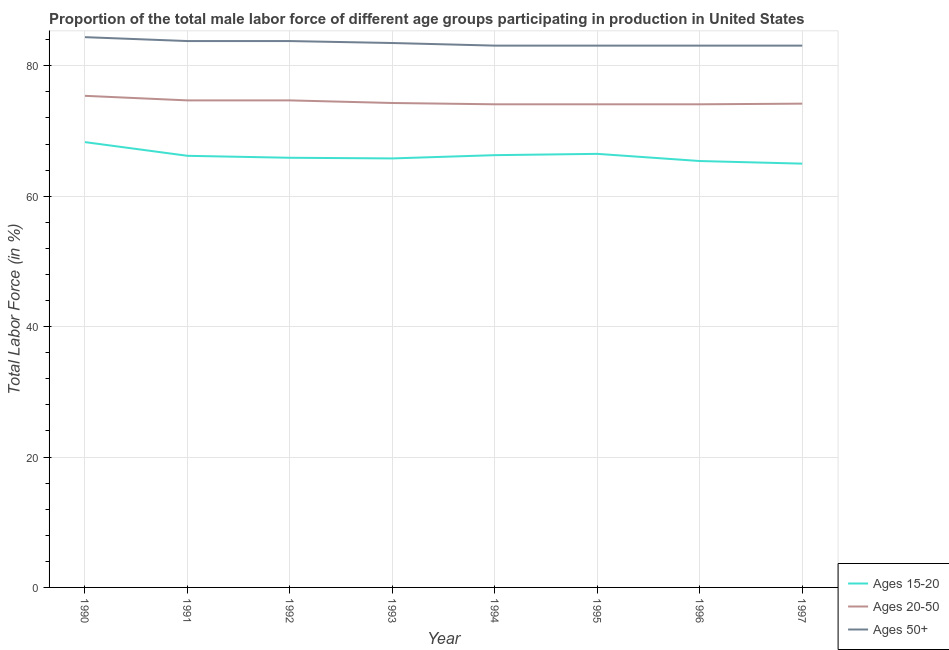How many different coloured lines are there?
Give a very brief answer. 3. What is the percentage of male labor force within the age group 20-50 in 1996?
Ensure brevity in your answer.  74.1. Across all years, what is the maximum percentage of male labor force within the age group 20-50?
Your answer should be very brief. 75.4. Across all years, what is the minimum percentage of male labor force within the age group 15-20?
Your answer should be compact. 65. What is the total percentage of male labor force above age 50 in the graph?
Make the answer very short. 667.9. What is the difference between the percentage of male labor force above age 50 in 1992 and that in 1997?
Your response must be concise. 0.7. What is the difference between the percentage of male labor force within the age group 20-50 in 1994 and the percentage of male labor force within the age group 15-20 in 1993?
Provide a succinct answer. 8.3. What is the average percentage of male labor force within the age group 15-20 per year?
Your answer should be very brief. 66.18. In the year 1997, what is the difference between the percentage of male labor force above age 50 and percentage of male labor force within the age group 15-20?
Offer a very short reply. 18.1. In how many years, is the percentage of male labor force above age 50 greater than 64 %?
Offer a very short reply. 8. What is the ratio of the percentage of male labor force within the age group 20-50 in 1992 to that in 1994?
Give a very brief answer. 1.01. Is the percentage of male labor force within the age group 15-20 in 1990 less than that in 1995?
Offer a terse response. No. Is the difference between the percentage of male labor force within the age group 15-20 in 1993 and 1994 greater than the difference between the percentage of male labor force within the age group 20-50 in 1993 and 1994?
Give a very brief answer. No. What is the difference between the highest and the second highest percentage of male labor force above age 50?
Offer a very short reply. 0.6. What is the difference between the highest and the lowest percentage of male labor force within the age group 20-50?
Provide a succinct answer. 1.3. Does the percentage of male labor force within the age group 15-20 monotonically increase over the years?
Offer a very short reply. No. Is the percentage of male labor force within the age group 15-20 strictly greater than the percentage of male labor force above age 50 over the years?
Your response must be concise. No. How many lines are there?
Make the answer very short. 3. How many years are there in the graph?
Provide a succinct answer. 8. Does the graph contain any zero values?
Provide a succinct answer. No. Does the graph contain grids?
Your response must be concise. Yes. What is the title of the graph?
Make the answer very short. Proportion of the total male labor force of different age groups participating in production in United States. What is the label or title of the X-axis?
Provide a succinct answer. Year. What is the Total Labor Force (in %) of Ages 15-20 in 1990?
Make the answer very short. 68.3. What is the Total Labor Force (in %) of Ages 20-50 in 1990?
Your response must be concise. 75.4. What is the Total Labor Force (in %) of Ages 50+ in 1990?
Provide a short and direct response. 84.4. What is the Total Labor Force (in %) in Ages 15-20 in 1991?
Offer a very short reply. 66.2. What is the Total Labor Force (in %) of Ages 20-50 in 1991?
Give a very brief answer. 74.7. What is the Total Labor Force (in %) in Ages 50+ in 1991?
Make the answer very short. 83.8. What is the Total Labor Force (in %) in Ages 15-20 in 1992?
Keep it short and to the point. 65.9. What is the Total Labor Force (in %) of Ages 20-50 in 1992?
Ensure brevity in your answer.  74.7. What is the Total Labor Force (in %) of Ages 50+ in 1992?
Offer a terse response. 83.8. What is the Total Labor Force (in %) of Ages 15-20 in 1993?
Offer a very short reply. 65.8. What is the Total Labor Force (in %) of Ages 20-50 in 1993?
Your response must be concise. 74.3. What is the Total Labor Force (in %) in Ages 50+ in 1993?
Offer a terse response. 83.5. What is the Total Labor Force (in %) of Ages 15-20 in 1994?
Your response must be concise. 66.3. What is the Total Labor Force (in %) of Ages 20-50 in 1994?
Provide a short and direct response. 74.1. What is the Total Labor Force (in %) in Ages 50+ in 1994?
Keep it short and to the point. 83.1. What is the Total Labor Force (in %) of Ages 15-20 in 1995?
Make the answer very short. 66.5. What is the Total Labor Force (in %) of Ages 20-50 in 1995?
Make the answer very short. 74.1. What is the Total Labor Force (in %) of Ages 50+ in 1995?
Offer a terse response. 83.1. What is the Total Labor Force (in %) of Ages 15-20 in 1996?
Give a very brief answer. 65.4. What is the Total Labor Force (in %) of Ages 20-50 in 1996?
Provide a short and direct response. 74.1. What is the Total Labor Force (in %) of Ages 50+ in 1996?
Give a very brief answer. 83.1. What is the Total Labor Force (in %) of Ages 20-50 in 1997?
Provide a succinct answer. 74.2. What is the Total Labor Force (in %) in Ages 50+ in 1997?
Offer a terse response. 83.1. Across all years, what is the maximum Total Labor Force (in %) in Ages 15-20?
Make the answer very short. 68.3. Across all years, what is the maximum Total Labor Force (in %) of Ages 20-50?
Offer a terse response. 75.4. Across all years, what is the maximum Total Labor Force (in %) of Ages 50+?
Your answer should be very brief. 84.4. Across all years, what is the minimum Total Labor Force (in %) of Ages 15-20?
Provide a succinct answer. 65. Across all years, what is the minimum Total Labor Force (in %) of Ages 20-50?
Keep it short and to the point. 74.1. Across all years, what is the minimum Total Labor Force (in %) in Ages 50+?
Make the answer very short. 83.1. What is the total Total Labor Force (in %) of Ages 15-20 in the graph?
Your answer should be compact. 529.4. What is the total Total Labor Force (in %) of Ages 20-50 in the graph?
Your answer should be very brief. 595.6. What is the total Total Labor Force (in %) of Ages 50+ in the graph?
Give a very brief answer. 667.9. What is the difference between the Total Labor Force (in %) in Ages 15-20 in 1990 and that in 1991?
Offer a very short reply. 2.1. What is the difference between the Total Labor Force (in %) of Ages 20-50 in 1990 and that in 1992?
Make the answer very short. 0.7. What is the difference between the Total Labor Force (in %) of Ages 50+ in 1990 and that in 1992?
Your response must be concise. 0.6. What is the difference between the Total Labor Force (in %) of Ages 20-50 in 1990 and that in 1993?
Give a very brief answer. 1.1. What is the difference between the Total Labor Force (in %) of Ages 50+ in 1990 and that in 1993?
Offer a very short reply. 0.9. What is the difference between the Total Labor Force (in %) in Ages 15-20 in 1990 and that in 1994?
Provide a succinct answer. 2. What is the difference between the Total Labor Force (in %) of Ages 50+ in 1990 and that in 1994?
Provide a succinct answer. 1.3. What is the difference between the Total Labor Force (in %) of Ages 15-20 in 1990 and that in 1995?
Provide a short and direct response. 1.8. What is the difference between the Total Labor Force (in %) of Ages 20-50 in 1990 and that in 1995?
Your answer should be very brief. 1.3. What is the difference between the Total Labor Force (in %) in Ages 50+ in 1990 and that in 1995?
Make the answer very short. 1.3. What is the difference between the Total Labor Force (in %) of Ages 20-50 in 1990 and that in 1996?
Offer a very short reply. 1.3. What is the difference between the Total Labor Force (in %) in Ages 50+ in 1990 and that in 1996?
Keep it short and to the point. 1.3. What is the difference between the Total Labor Force (in %) in Ages 15-20 in 1990 and that in 1997?
Offer a very short reply. 3.3. What is the difference between the Total Labor Force (in %) in Ages 50+ in 1990 and that in 1997?
Provide a short and direct response. 1.3. What is the difference between the Total Labor Force (in %) in Ages 15-20 in 1991 and that in 1992?
Give a very brief answer. 0.3. What is the difference between the Total Labor Force (in %) in Ages 20-50 in 1991 and that in 1992?
Provide a short and direct response. 0. What is the difference between the Total Labor Force (in %) in Ages 50+ in 1991 and that in 1992?
Your response must be concise. 0. What is the difference between the Total Labor Force (in %) of Ages 20-50 in 1991 and that in 1993?
Your response must be concise. 0.4. What is the difference between the Total Labor Force (in %) in Ages 50+ in 1991 and that in 1993?
Keep it short and to the point. 0.3. What is the difference between the Total Labor Force (in %) of Ages 15-20 in 1991 and that in 1995?
Offer a terse response. -0.3. What is the difference between the Total Labor Force (in %) of Ages 15-20 in 1991 and that in 1996?
Give a very brief answer. 0.8. What is the difference between the Total Labor Force (in %) in Ages 50+ in 1991 and that in 1996?
Your response must be concise. 0.7. What is the difference between the Total Labor Force (in %) in Ages 15-20 in 1991 and that in 1997?
Your answer should be compact. 1.2. What is the difference between the Total Labor Force (in %) in Ages 50+ in 1991 and that in 1997?
Offer a very short reply. 0.7. What is the difference between the Total Labor Force (in %) in Ages 15-20 in 1992 and that in 1994?
Your response must be concise. -0.4. What is the difference between the Total Labor Force (in %) of Ages 20-50 in 1992 and that in 1994?
Offer a very short reply. 0.6. What is the difference between the Total Labor Force (in %) in Ages 50+ in 1992 and that in 1994?
Your answer should be compact. 0.7. What is the difference between the Total Labor Force (in %) in Ages 50+ in 1992 and that in 1996?
Provide a succinct answer. 0.7. What is the difference between the Total Labor Force (in %) in Ages 50+ in 1993 and that in 1995?
Provide a succinct answer. 0.4. What is the difference between the Total Labor Force (in %) of Ages 50+ in 1993 and that in 1996?
Keep it short and to the point. 0.4. What is the difference between the Total Labor Force (in %) in Ages 15-20 in 1993 and that in 1997?
Provide a short and direct response. 0.8. What is the difference between the Total Labor Force (in %) of Ages 20-50 in 1994 and that in 1995?
Keep it short and to the point. 0. What is the difference between the Total Labor Force (in %) in Ages 50+ in 1994 and that in 1995?
Your answer should be very brief. 0. What is the difference between the Total Labor Force (in %) of Ages 50+ in 1995 and that in 1996?
Provide a short and direct response. 0. What is the difference between the Total Labor Force (in %) in Ages 15-20 in 1995 and that in 1997?
Offer a terse response. 1.5. What is the difference between the Total Labor Force (in %) of Ages 15-20 in 1996 and that in 1997?
Keep it short and to the point. 0.4. What is the difference between the Total Labor Force (in %) in Ages 15-20 in 1990 and the Total Labor Force (in %) in Ages 50+ in 1991?
Keep it short and to the point. -15.5. What is the difference between the Total Labor Force (in %) of Ages 20-50 in 1990 and the Total Labor Force (in %) of Ages 50+ in 1991?
Your response must be concise. -8.4. What is the difference between the Total Labor Force (in %) in Ages 15-20 in 1990 and the Total Labor Force (in %) in Ages 20-50 in 1992?
Provide a succinct answer. -6.4. What is the difference between the Total Labor Force (in %) in Ages 15-20 in 1990 and the Total Labor Force (in %) in Ages 50+ in 1992?
Make the answer very short. -15.5. What is the difference between the Total Labor Force (in %) of Ages 15-20 in 1990 and the Total Labor Force (in %) of Ages 50+ in 1993?
Give a very brief answer. -15.2. What is the difference between the Total Labor Force (in %) in Ages 15-20 in 1990 and the Total Labor Force (in %) in Ages 20-50 in 1994?
Ensure brevity in your answer.  -5.8. What is the difference between the Total Labor Force (in %) of Ages 15-20 in 1990 and the Total Labor Force (in %) of Ages 50+ in 1994?
Your response must be concise. -14.8. What is the difference between the Total Labor Force (in %) in Ages 20-50 in 1990 and the Total Labor Force (in %) in Ages 50+ in 1994?
Keep it short and to the point. -7.7. What is the difference between the Total Labor Force (in %) in Ages 15-20 in 1990 and the Total Labor Force (in %) in Ages 20-50 in 1995?
Your response must be concise. -5.8. What is the difference between the Total Labor Force (in %) in Ages 15-20 in 1990 and the Total Labor Force (in %) in Ages 50+ in 1995?
Keep it short and to the point. -14.8. What is the difference between the Total Labor Force (in %) in Ages 20-50 in 1990 and the Total Labor Force (in %) in Ages 50+ in 1995?
Your response must be concise. -7.7. What is the difference between the Total Labor Force (in %) in Ages 15-20 in 1990 and the Total Labor Force (in %) in Ages 50+ in 1996?
Ensure brevity in your answer.  -14.8. What is the difference between the Total Labor Force (in %) of Ages 20-50 in 1990 and the Total Labor Force (in %) of Ages 50+ in 1996?
Offer a terse response. -7.7. What is the difference between the Total Labor Force (in %) of Ages 15-20 in 1990 and the Total Labor Force (in %) of Ages 20-50 in 1997?
Make the answer very short. -5.9. What is the difference between the Total Labor Force (in %) in Ages 15-20 in 1990 and the Total Labor Force (in %) in Ages 50+ in 1997?
Your answer should be compact. -14.8. What is the difference between the Total Labor Force (in %) of Ages 20-50 in 1990 and the Total Labor Force (in %) of Ages 50+ in 1997?
Your answer should be very brief. -7.7. What is the difference between the Total Labor Force (in %) in Ages 15-20 in 1991 and the Total Labor Force (in %) in Ages 20-50 in 1992?
Offer a very short reply. -8.5. What is the difference between the Total Labor Force (in %) in Ages 15-20 in 1991 and the Total Labor Force (in %) in Ages 50+ in 1992?
Your response must be concise. -17.6. What is the difference between the Total Labor Force (in %) in Ages 15-20 in 1991 and the Total Labor Force (in %) in Ages 20-50 in 1993?
Offer a very short reply. -8.1. What is the difference between the Total Labor Force (in %) in Ages 15-20 in 1991 and the Total Labor Force (in %) in Ages 50+ in 1993?
Offer a terse response. -17.3. What is the difference between the Total Labor Force (in %) in Ages 20-50 in 1991 and the Total Labor Force (in %) in Ages 50+ in 1993?
Ensure brevity in your answer.  -8.8. What is the difference between the Total Labor Force (in %) of Ages 15-20 in 1991 and the Total Labor Force (in %) of Ages 20-50 in 1994?
Your answer should be very brief. -7.9. What is the difference between the Total Labor Force (in %) of Ages 15-20 in 1991 and the Total Labor Force (in %) of Ages 50+ in 1994?
Provide a short and direct response. -16.9. What is the difference between the Total Labor Force (in %) of Ages 15-20 in 1991 and the Total Labor Force (in %) of Ages 50+ in 1995?
Provide a succinct answer. -16.9. What is the difference between the Total Labor Force (in %) in Ages 15-20 in 1991 and the Total Labor Force (in %) in Ages 20-50 in 1996?
Provide a short and direct response. -7.9. What is the difference between the Total Labor Force (in %) of Ages 15-20 in 1991 and the Total Labor Force (in %) of Ages 50+ in 1996?
Make the answer very short. -16.9. What is the difference between the Total Labor Force (in %) of Ages 20-50 in 1991 and the Total Labor Force (in %) of Ages 50+ in 1996?
Keep it short and to the point. -8.4. What is the difference between the Total Labor Force (in %) in Ages 15-20 in 1991 and the Total Labor Force (in %) in Ages 20-50 in 1997?
Your answer should be very brief. -8. What is the difference between the Total Labor Force (in %) of Ages 15-20 in 1991 and the Total Labor Force (in %) of Ages 50+ in 1997?
Provide a short and direct response. -16.9. What is the difference between the Total Labor Force (in %) of Ages 15-20 in 1992 and the Total Labor Force (in %) of Ages 50+ in 1993?
Keep it short and to the point. -17.6. What is the difference between the Total Labor Force (in %) of Ages 15-20 in 1992 and the Total Labor Force (in %) of Ages 50+ in 1994?
Provide a short and direct response. -17.2. What is the difference between the Total Labor Force (in %) of Ages 15-20 in 1992 and the Total Labor Force (in %) of Ages 20-50 in 1995?
Offer a terse response. -8.2. What is the difference between the Total Labor Force (in %) in Ages 15-20 in 1992 and the Total Labor Force (in %) in Ages 50+ in 1995?
Ensure brevity in your answer.  -17.2. What is the difference between the Total Labor Force (in %) in Ages 15-20 in 1992 and the Total Labor Force (in %) in Ages 20-50 in 1996?
Ensure brevity in your answer.  -8.2. What is the difference between the Total Labor Force (in %) in Ages 15-20 in 1992 and the Total Labor Force (in %) in Ages 50+ in 1996?
Your answer should be compact. -17.2. What is the difference between the Total Labor Force (in %) of Ages 15-20 in 1992 and the Total Labor Force (in %) of Ages 20-50 in 1997?
Your answer should be very brief. -8.3. What is the difference between the Total Labor Force (in %) in Ages 15-20 in 1992 and the Total Labor Force (in %) in Ages 50+ in 1997?
Make the answer very short. -17.2. What is the difference between the Total Labor Force (in %) in Ages 15-20 in 1993 and the Total Labor Force (in %) in Ages 20-50 in 1994?
Offer a very short reply. -8.3. What is the difference between the Total Labor Force (in %) of Ages 15-20 in 1993 and the Total Labor Force (in %) of Ages 50+ in 1994?
Your response must be concise. -17.3. What is the difference between the Total Labor Force (in %) of Ages 20-50 in 1993 and the Total Labor Force (in %) of Ages 50+ in 1994?
Give a very brief answer. -8.8. What is the difference between the Total Labor Force (in %) in Ages 15-20 in 1993 and the Total Labor Force (in %) in Ages 20-50 in 1995?
Keep it short and to the point. -8.3. What is the difference between the Total Labor Force (in %) of Ages 15-20 in 1993 and the Total Labor Force (in %) of Ages 50+ in 1995?
Provide a succinct answer. -17.3. What is the difference between the Total Labor Force (in %) of Ages 20-50 in 1993 and the Total Labor Force (in %) of Ages 50+ in 1995?
Offer a very short reply. -8.8. What is the difference between the Total Labor Force (in %) of Ages 15-20 in 1993 and the Total Labor Force (in %) of Ages 50+ in 1996?
Offer a very short reply. -17.3. What is the difference between the Total Labor Force (in %) of Ages 20-50 in 1993 and the Total Labor Force (in %) of Ages 50+ in 1996?
Ensure brevity in your answer.  -8.8. What is the difference between the Total Labor Force (in %) of Ages 15-20 in 1993 and the Total Labor Force (in %) of Ages 20-50 in 1997?
Provide a short and direct response. -8.4. What is the difference between the Total Labor Force (in %) in Ages 15-20 in 1993 and the Total Labor Force (in %) in Ages 50+ in 1997?
Make the answer very short. -17.3. What is the difference between the Total Labor Force (in %) of Ages 20-50 in 1993 and the Total Labor Force (in %) of Ages 50+ in 1997?
Provide a short and direct response. -8.8. What is the difference between the Total Labor Force (in %) of Ages 15-20 in 1994 and the Total Labor Force (in %) of Ages 20-50 in 1995?
Keep it short and to the point. -7.8. What is the difference between the Total Labor Force (in %) of Ages 15-20 in 1994 and the Total Labor Force (in %) of Ages 50+ in 1995?
Your answer should be compact. -16.8. What is the difference between the Total Labor Force (in %) of Ages 15-20 in 1994 and the Total Labor Force (in %) of Ages 50+ in 1996?
Make the answer very short. -16.8. What is the difference between the Total Labor Force (in %) in Ages 20-50 in 1994 and the Total Labor Force (in %) in Ages 50+ in 1996?
Provide a short and direct response. -9. What is the difference between the Total Labor Force (in %) in Ages 15-20 in 1994 and the Total Labor Force (in %) in Ages 50+ in 1997?
Offer a very short reply. -16.8. What is the difference between the Total Labor Force (in %) of Ages 15-20 in 1995 and the Total Labor Force (in %) of Ages 50+ in 1996?
Make the answer very short. -16.6. What is the difference between the Total Labor Force (in %) of Ages 15-20 in 1995 and the Total Labor Force (in %) of Ages 50+ in 1997?
Provide a short and direct response. -16.6. What is the difference between the Total Labor Force (in %) of Ages 20-50 in 1995 and the Total Labor Force (in %) of Ages 50+ in 1997?
Offer a very short reply. -9. What is the difference between the Total Labor Force (in %) of Ages 15-20 in 1996 and the Total Labor Force (in %) of Ages 50+ in 1997?
Keep it short and to the point. -17.7. What is the difference between the Total Labor Force (in %) of Ages 20-50 in 1996 and the Total Labor Force (in %) of Ages 50+ in 1997?
Your response must be concise. -9. What is the average Total Labor Force (in %) of Ages 15-20 per year?
Make the answer very short. 66.17. What is the average Total Labor Force (in %) of Ages 20-50 per year?
Offer a very short reply. 74.45. What is the average Total Labor Force (in %) in Ages 50+ per year?
Your answer should be very brief. 83.49. In the year 1990, what is the difference between the Total Labor Force (in %) in Ages 15-20 and Total Labor Force (in %) in Ages 50+?
Your answer should be very brief. -16.1. In the year 1991, what is the difference between the Total Labor Force (in %) of Ages 15-20 and Total Labor Force (in %) of Ages 20-50?
Keep it short and to the point. -8.5. In the year 1991, what is the difference between the Total Labor Force (in %) of Ages 15-20 and Total Labor Force (in %) of Ages 50+?
Ensure brevity in your answer.  -17.6. In the year 1991, what is the difference between the Total Labor Force (in %) in Ages 20-50 and Total Labor Force (in %) in Ages 50+?
Offer a terse response. -9.1. In the year 1992, what is the difference between the Total Labor Force (in %) of Ages 15-20 and Total Labor Force (in %) of Ages 20-50?
Offer a very short reply. -8.8. In the year 1992, what is the difference between the Total Labor Force (in %) in Ages 15-20 and Total Labor Force (in %) in Ages 50+?
Your response must be concise. -17.9. In the year 1992, what is the difference between the Total Labor Force (in %) in Ages 20-50 and Total Labor Force (in %) in Ages 50+?
Your answer should be very brief. -9.1. In the year 1993, what is the difference between the Total Labor Force (in %) of Ages 15-20 and Total Labor Force (in %) of Ages 20-50?
Keep it short and to the point. -8.5. In the year 1993, what is the difference between the Total Labor Force (in %) of Ages 15-20 and Total Labor Force (in %) of Ages 50+?
Make the answer very short. -17.7. In the year 1994, what is the difference between the Total Labor Force (in %) of Ages 15-20 and Total Labor Force (in %) of Ages 20-50?
Your answer should be compact. -7.8. In the year 1994, what is the difference between the Total Labor Force (in %) of Ages 15-20 and Total Labor Force (in %) of Ages 50+?
Give a very brief answer. -16.8. In the year 1995, what is the difference between the Total Labor Force (in %) of Ages 15-20 and Total Labor Force (in %) of Ages 50+?
Make the answer very short. -16.6. In the year 1995, what is the difference between the Total Labor Force (in %) in Ages 20-50 and Total Labor Force (in %) in Ages 50+?
Make the answer very short. -9. In the year 1996, what is the difference between the Total Labor Force (in %) in Ages 15-20 and Total Labor Force (in %) in Ages 20-50?
Your response must be concise. -8.7. In the year 1996, what is the difference between the Total Labor Force (in %) in Ages 15-20 and Total Labor Force (in %) in Ages 50+?
Make the answer very short. -17.7. In the year 1997, what is the difference between the Total Labor Force (in %) of Ages 15-20 and Total Labor Force (in %) of Ages 20-50?
Provide a short and direct response. -9.2. In the year 1997, what is the difference between the Total Labor Force (in %) of Ages 15-20 and Total Labor Force (in %) of Ages 50+?
Ensure brevity in your answer.  -18.1. In the year 1997, what is the difference between the Total Labor Force (in %) of Ages 20-50 and Total Labor Force (in %) of Ages 50+?
Provide a succinct answer. -8.9. What is the ratio of the Total Labor Force (in %) of Ages 15-20 in 1990 to that in 1991?
Make the answer very short. 1.03. What is the ratio of the Total Labor Force (in %) of Ages 20-50 in 1990 to that in 1991?
Offer a very short reply. 1.01. What is the ratio of the Total Labor Force (in %) in Ages 15-20 in 1990 to that in 1992?
Offer a very short reply. 1.04. What is the ratio of the Total Labor Force (in %) in Ages 20-50 in 1990 to that in 1992?
Your answer should be very brief. 1.01. What is the ratio of the Total Labor Force (in %) in Ages 15-20 in 1990 to that in 1993?
Keep it short and to the point. 1.04. What is the ratio of the Total Labor Force (in %) of Ages 20-50 in 1990 to that in 1993?
Provide a short and direct response. 1.01. What is the ratio of the Total Labor Force (in %) in Ages 50+ in 1990 to that in 1993?
Keep it short and to the point. 1.01. What is the ratio of the Total Labor Force (in %) in Ages 15-20 in 1990 to that in 1994?
Provide a short and direct response. 1.03. What is the ratio of the Total Labor Force (in %) in Ages 20-50 in 1990 to that in 1994?
Offer a terse response. 1.02. What is the ratio of the Total Labor Force (in %) of Ages 50+ in 1990 to that in 1994?
Your answer should be very brief. 1.02. What is the ratio of the Total Labor Force (in %) in Ages 15-20 in 1990 to that in 1995?
Keep it short and to the point. 1.03. What is the ratio of the Total Labor Force (in %) of Ages 20-50 in 1990 to that in 1995?
Ensure brevity in your answer.  1.02. What is the ratio of the Total Labor Force (in %) of Ages 50+ in 1990 to that in 1995?
Your answer should be compact. 1.02. What is the ratio of the Total Labor Force (in %) of Ages 15-20 in 1990 to that in 1996?
Offer a very short reply. 1.04. What is the ratio of the Total Labor Force (in %) in Ages 20-50 in 1990 to that in 1996?
Your answer should be very brief. 1.02. What is the ratio of the Total Labor Force (in %) in Ages 50+ in 1990 to that in 1996?
Ensure brevity in your answer.  1.02. What is the ratio of the Total Labor Force (in %) in Ages 15-20 in 1990 to that in 1997?
Your response must be concise. 1.05. What is the ratio of the Total Labor Force (in %) in Ages 20-50 in 1990 to that in 1997?
Offer a very short reply. 1.02. What is the ratio of the Total Labor Force (in %) in Ages 50+ in 1990 to that in 1997?
Make the answer very short. 1.02. What is the ratio of the Total Labor Force (in %) of Ages 20-50 in 1991 to that in 1993?
Provide a short and direct response. 1.01. What is the ratio of the Total Labor Force (in %) of Ages 50+ in 1991 to that in 1993?
Offer a terse response. 1. What is the ratio of the Total Labor Force (in %) of Ages 15-20 in 1991 to that in 1994?
Ensure brevity in your answer.  1. What is the ratio of the Total Labor Force (in %) in Ages 20-50 in 1991 to that in 1994?
Keep it short and to the point. 1.01. What is the ratio of the Total Labor Force (in %) in Ages 50+ in 1991 to that in 1994?
Ensure brevity in your answer.  1.01. What is the ratio of the Total Labor Force (in %) in Ages 15-20 in 1991 to that in 1995?
Provide a short and direct response. 1. What is the ratio of the Total Labor Force (in %) in Ages 20-50 in 1991 to that in 1995?
Make the answer very short. 1.01. What is the ratio of the Total Labor Force (in %) in Ages 50+ in 1991 to that in 1995?
Offer a very short reply. 1.01. What is the ratio of the Total Labor Force (in %) in Ages 15-20 in 1991 to that in 1996?
Offer a terse response. 1.01. What is the ratio of the Total Labor Force (in %) of Ages 20-50 in 1991 to that in 1996?
Your answer should be compact. 1.01. What is the ratio of the Total Labor Force (in %) in Ages 50+ in 1991 to that in 1996?
Keep it short and to the point. 1.01. What is the ratio of the Total Labor Force (in %) in Ages 15-20 in 1991 to that in 1997?
Give a very brief answer. 1.02. What is the ratio of the Total Labor Force (in %) of Ages 20-50 in 1991 to that in 1997?
Your response must be concise. 1.01. What is the ratio of the Total Labor Force (in %) in Ages 50+ in 1991 to that in 1997?
Provide a succinct answer. 1.01. What is the ratio of the Total Labor Force (in %) in Ages 15-20 in 1992 to that in 1993?
Ensure brevity in your answer.  1. What is the ratio of the Total Labor Force (in %) of Ages 20-50 in 1992 to that in 1993?
Offer a terse response. 1.01. What is the ratio of the Total Labor Force (in %) of Ages 50+ in 1992 to that in 1994?
Ensure brevity in your answer.  1.01. What is the ratio of the Total Labor Force (in %) in Ages 50+ in 1992 to that in 1995?
Provide a succinct answer. 1.01. What is the ratio of the Total Labor Force (in %) of Ages 15-20 in 1992 to that in 1996?
Provide a succinct answer. 1.01. What is the ratio of the Total Labor Force (in %) in Ages 50+ in 1992 to that in 1996?
Ensure brevity in your answer.  1.01. What is the ratio of the Total Labor Force (in %) of Ages 15-20 in 1992 to that in 1997?
Your response must be concise. 1.01. What is the ratio of the Total Labor Force (in %) in Ages 20-50 in 1992 to that in 1997?
Ensure brevity in your answer.  1.01. What is the ratio of the Total Labor Force (in %) of Ages 50+ in 1992 to that in 1997?
Offer a very short reply. 1.01. What is the ratio of the Total Labor Force (in %) of Ages 15-20 in 1993 to that in 1994?
Keep it short and to the point. 0.99. What is the ratio of the Total Labor Force (in %) of Ages 50+ in 1993 to that in 1994?
Give a very brief answer. 1. What is the ratio of the Total Labor Force (in %) in Ages 15-20 in 1993 to that in 1997?
Provide a short and direct response. 1.01. What is the ratio of the Total Labor Force (in %) in Ages 50+ in 1993 to that in 1997?
Provide a succinct answer. 1. What is the ratio of the Total Labor Force (in %) of Ages 15-20 in 1994 to that in 1995?
Your answer should be compact. 1. What is the ratio of the Total Labor Force (in %) in Ages 20-50 in 1994 to that in 1995?
Your answer should be very brief. 1. What is the ratio of the Total Labor Force (in %) of Ages 15-20 in 1994 to that in 1996?
Your answer should be compact. 1.01. What is the ratio of the Total Labor Force (in %) in Ages 20-50 in 1994 to that in 1996?
Provide a succinct answer. 1. What is the ratio of the Total Labor Force (in %) of Ages 50+ in 1994 to that in 1996?
Ensure brevity in your answer.  1. What is the ratio of the Total Labor Force (in %) of Ages 20-50 in 1994 to that in 1997?
Keep it short and to the point. 1. What is the ratio of the Total Labor Force (in %) of Ages 15-20 in 1995 to that in 1996?
Provide a short and direct response. 1.02. What is the ratio of the Total Labor Force (in %) of Ages 15-20 in 1995 to that in 1997?
Provide a short and direct response. 1.02. What is the ratio of the Total Labor Force (in %) of Ages 15-20 in 1996 to that in 1997?
Your response must be concise. 1.01. What is the ratio of the Total Labor Force (in %) in Ages 50+ in 1996 to that in 1997?
Ensure brevity in your answer.  1. What is the difference between the highest and the second highest Total Labor Force (in %) of Ages 20-50?
Offer a very short reply. 0.7. What is the difference between the highest and the lowest Total Labor Force (in %) of Ages 15-20?
Make the answer very short. 3.3. 